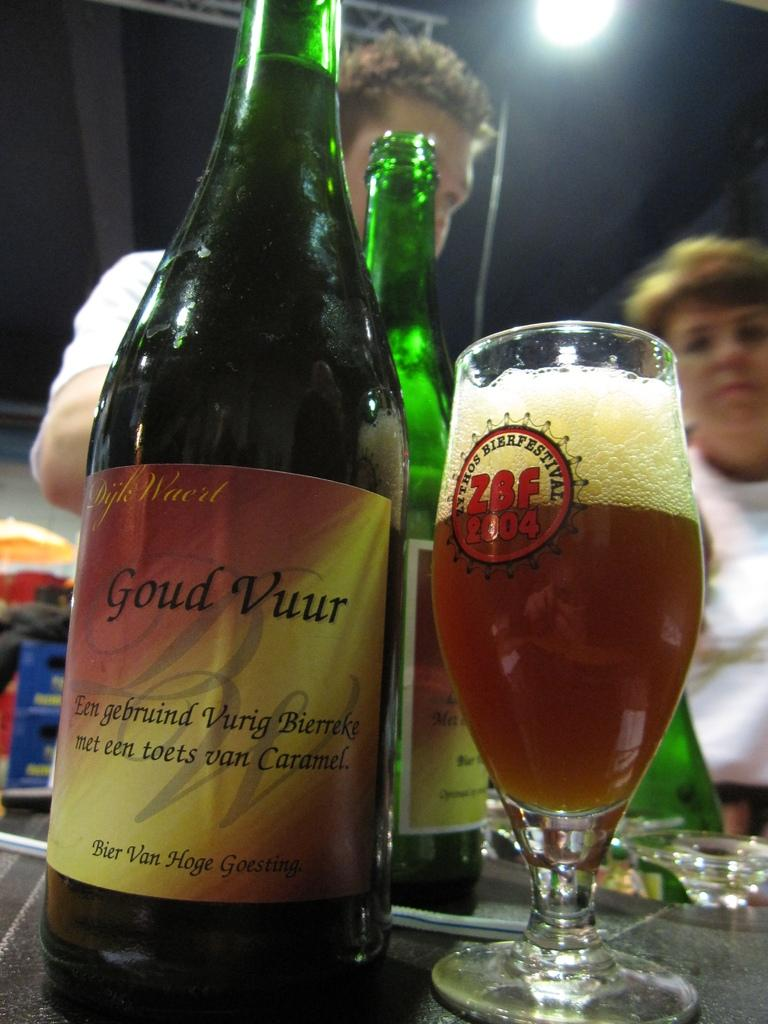Provide a one-sentence caption for the provided image. A glass of beer is from a 2004 festival. 